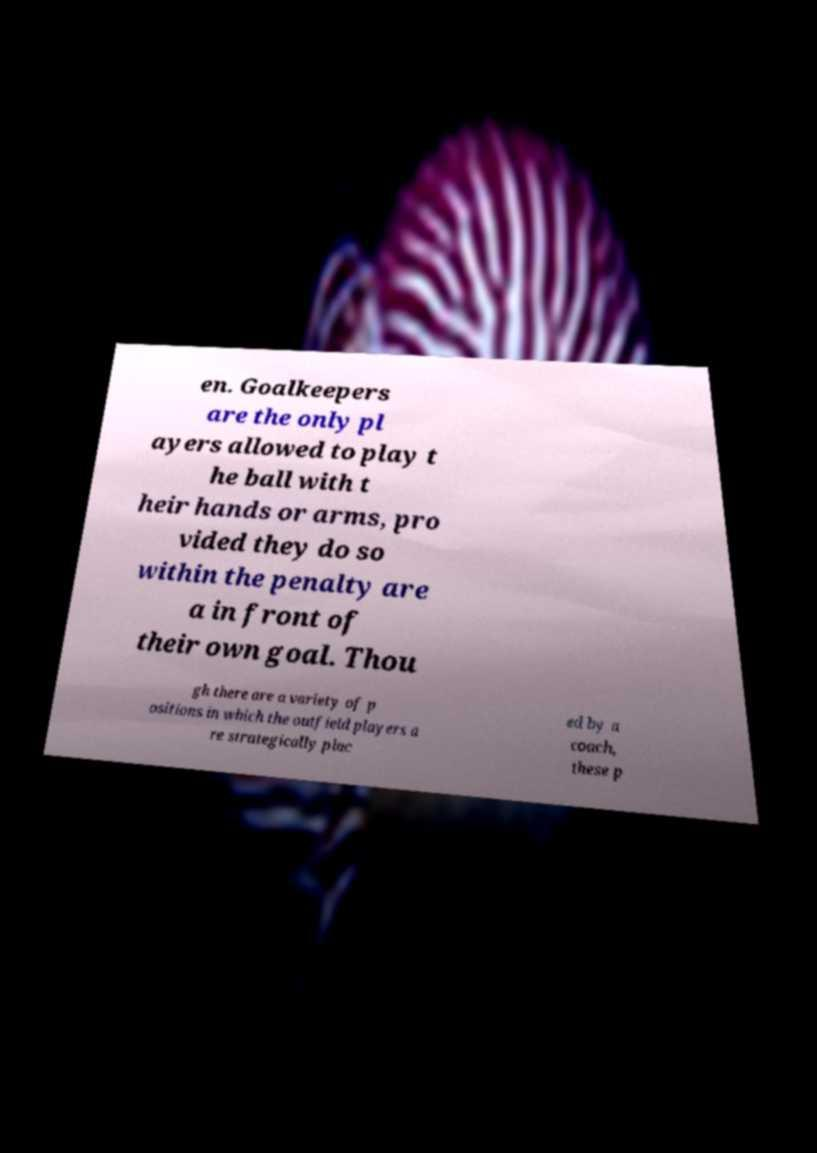Please read and relay the text visible in this image. What does it say? en. Goalkeepers are the only pl ayers allowed to play t he ball with t heir hands or arms, pro vided they do so within the penalty are a in front of their own goal. Thou gh there are a variety of p ositions in which the outfield players a re strategically plac ed by a coach, these p 